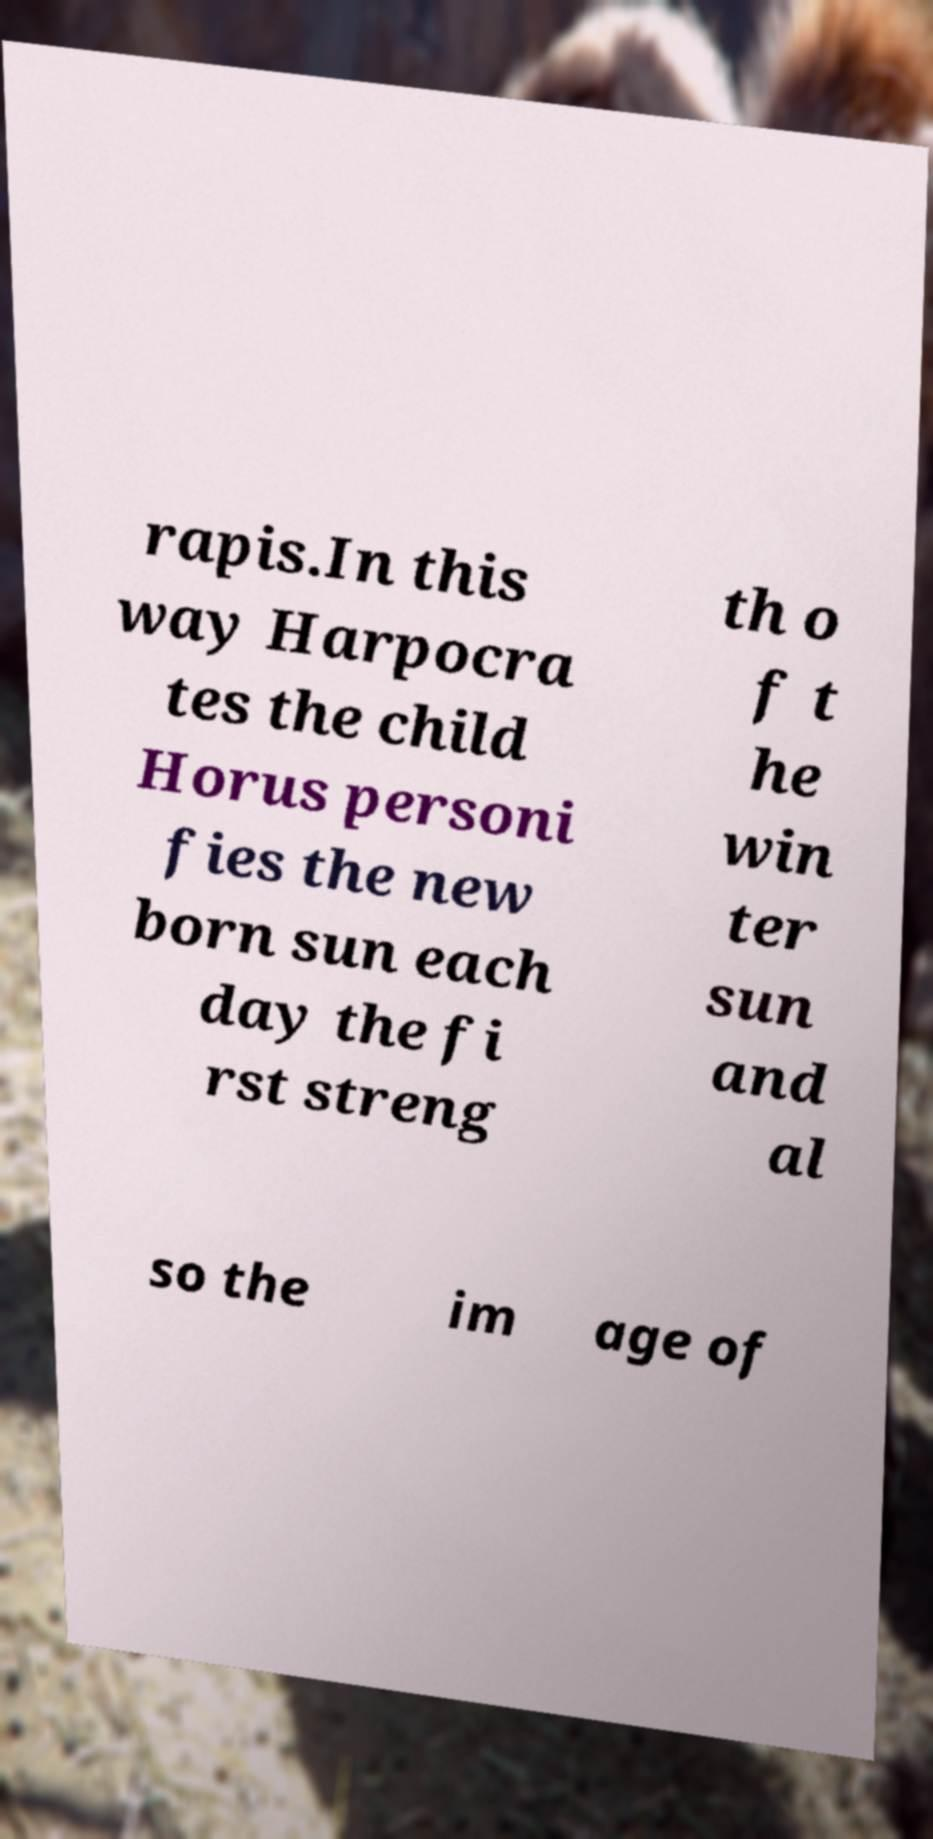There's text embedded in this image that I need extracted. Can you transcribe it verbatim? rapis.In this way Harpocra tes the child Horus personi fies the new born sun each day the fi rst streng th o f t he win ter sun and al so the im age of 